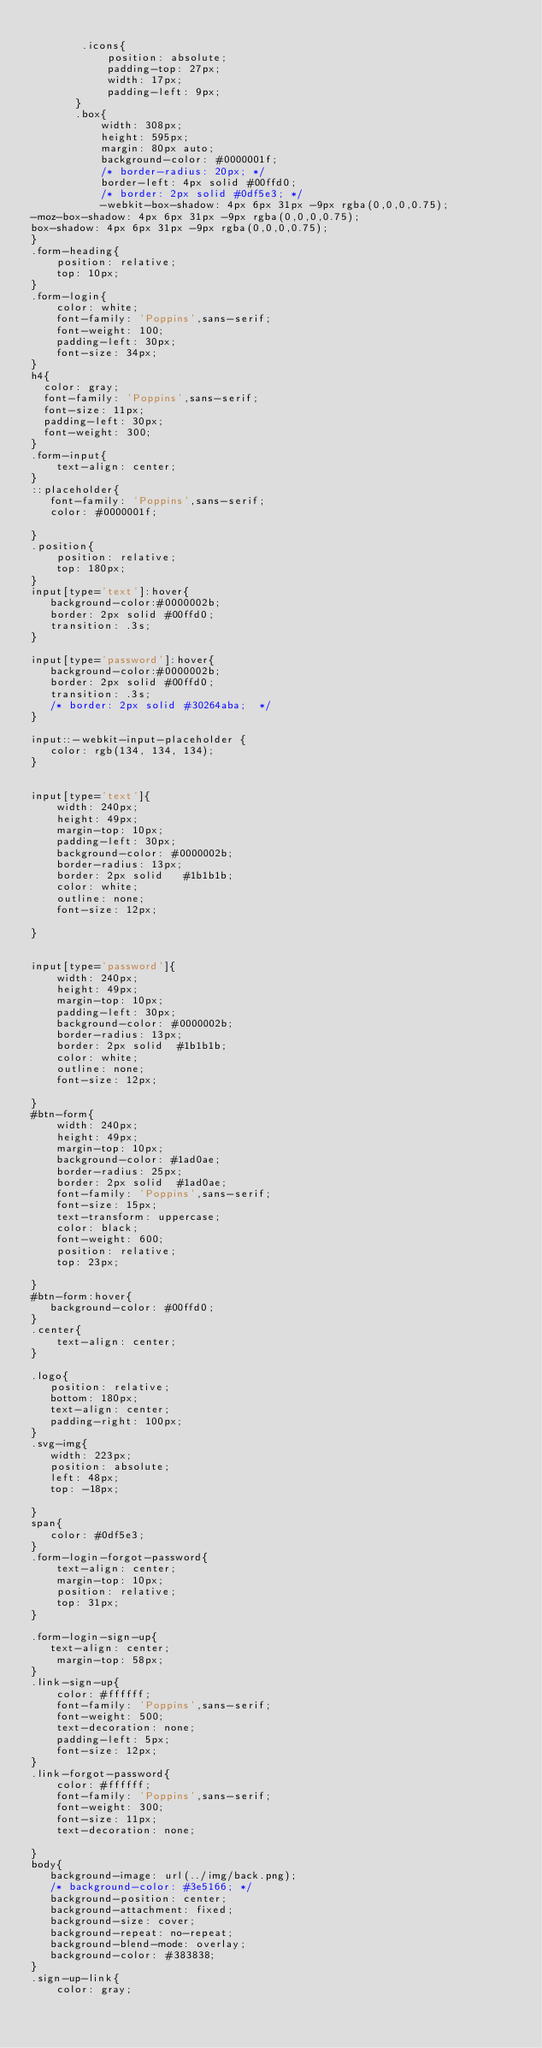Convert code to text. <code><loc_0><loc_0><loc_500><loc_500><_CSS_>      
        .icons{
            position: absolute;
            padding-top: 27px;
            width: 17px;
            padding-left: 9px;
       }
       .box{
           width: 308px;
           height: 595px;
           margin: 80px auto;
           background-color: #0000001f;
           /* border-radius: 20px; */
           border-left: 4px solid #00ffd0;
           /* border: 2px solid #0df5e3; */
           -webkit-box-shadow: 4px 6px 31px -9px rgba(0,0,0,0.75);
-moz-box-shadow: 4px 6px 31px -9px rgba(0,0,0,0.75);
box-shadow: 4px 6px 31px -9px rgba(0,0,0,0.75);
}
.form-heading{
    position: relative; 
    top: 10px;
}
.form-login{
    color: white;
    font-family: 'Poppins',sans-serif;
    font-weight: 100;
    padding-left: 30px;
    font-size: 34px;
}    
h4{
  color: gray;  
  font-family: 'Poppins',sans-serif;
  font-size: 11px;
  padding-left: 30px;
  font-weight: 300;
}
.form-input{
    text-align: center;
}
::placeholder{
   font-family: 'Poppins',sans-serif;
   color: #0000001f;
   
}
.position{
    position: relative; 
    top: 180px;
}
input[type='text']:hover{
   background-color:#0000002b;
   border: 2px solid #00ffd0;
   transition: .3s;
}

input[type='password']:hover{
   background-color:#0000002b;
   border: 2px solid #00ffd0;
   transition: .3s;
   /* border: 2px solid #30264aba;  */
}

input::-webkit-input-placeholder {
   color: rgb(134, 134, 134);
}


input[type='text']{
    width: 240px;
    height: 49px;
    margin-top: 10px;
    padding-left: 30px;
    background-color: #0000002b;
    border-radius: 13px;
    border: 2px solid   #1b1b1b;
    color: white;
    outline: none;
    font-size: 12px;
    
} 


input[type='password']{
    width: 240px;
    height: 49px;
    margin-top: 10px;
    padding-left: 30px;
    background-color: #0000002b;
    border-radius: 13px;
    border: 2px solid  #1b1b1b;
    color: white;
    outline: none;
    font-size: 12px;
    
} 
#btn-form{
    width: 240px;
    height: 49px;
    margin-top: 10px;
    background-color: #1ad0ae;
    border-radius: 25px;
    border: 2px solid  #1ad0ae;
    font-family: 'Poppins',sans-serif;
    font-size: 15px;
    text-transform: uppercase;
    color: black;
    font-weight: 600;
    position: relative;
    top: 23px;
    
} 
#btn-form:hover{
   background-color: #00ffd0;
}
.center{
    text-align: center;
}

.logo{
   position: relative; 
   bottom: 180px;
   text-align: center; 
   padding-right: 100px;
}
.svg-img{
   width: 223px;
   position: absolute;
   left: 48px;
   top: -18px;
   
}
span{
   color: #0df5e3;
}
.form-login-forgot-password{
    text-align: center;
    margin-top: 10px;
    position: relative; 
    top: 31px;
}

.form-login-sign-up{
   text-align: center;
    margin-top: 58px;
}
.link-sign-up{
    color: #ffffff;
    font-family: 'Poppins',sans-serif;
    font-weight: 500;
    text-decoration: none;
    padding-left: 5px;
    font-size: 12px;
}
.link-forgot-password{
    color: #ffffff;
    font-family: 'Poppins',sans-serif;
    font-weight: 300;
    font-size: 11px;
    text-decoration: none;

} 
body{
   background-image: url(../img/back.png);
   /* background-color: #3e5166; */
   background-position: center;
   background-attachment: fixed;
   background-size: cover;
   background-repeat: no-repeat;
   background-blend-mode: overlay;
   background-color: #383838;
}
.sign-up-link{
    color: gray;</code> 